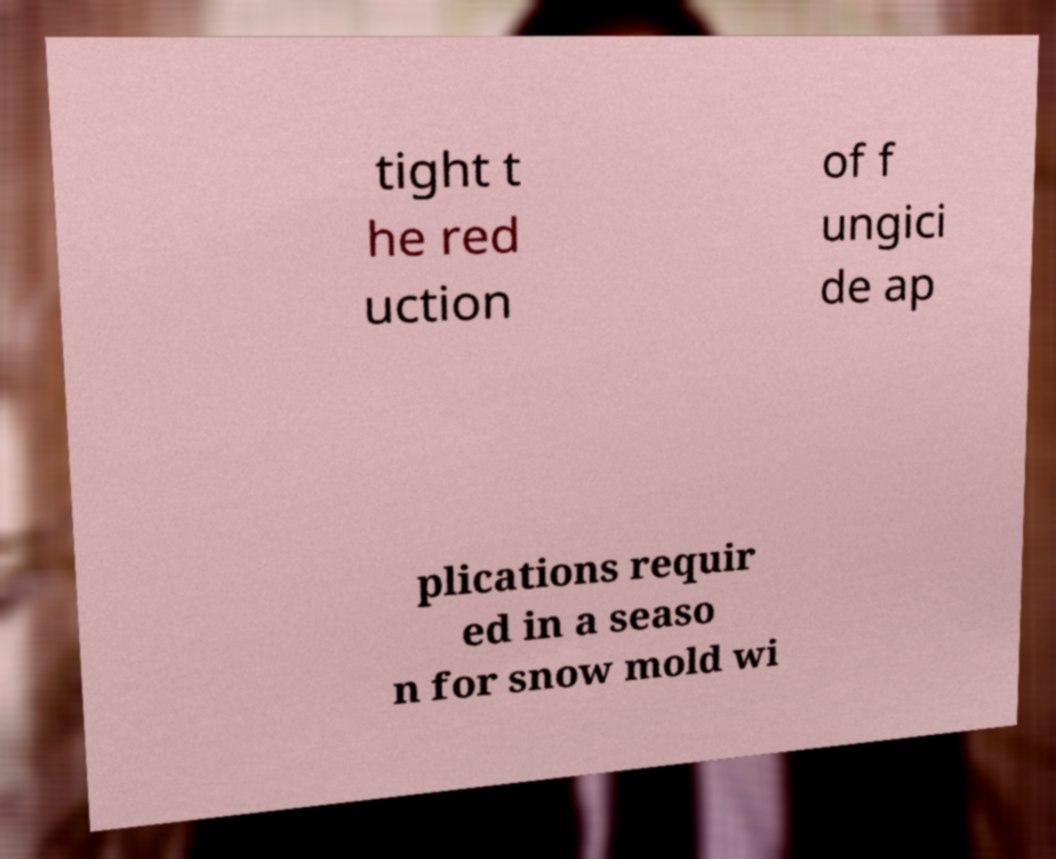There's text embedded in this image that I need extracted. Can you transcribe it verbatim? tight t he red uction of f ungici de ap plications requir ed in a seaso n for snow mold wi 